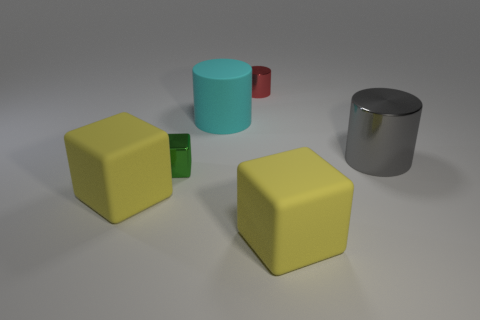Subtract all red cylinders. How many yellow blocks are left? 2 Subtract 1 cylinders. How many cylinders are left? 2 Add 2 large cyan cylinders. How many objects exist? 8 Subtract all green shiny things. Subtract all big cyan cylinders. How many objects are left? 4 Add 2 yellow matte things. How many yellow matte things are left? 4 Add 6 tiny red metallic things. How many tiny red metallic things exist? 7 Subtract 0 red blocks. How many objects are left? 6 